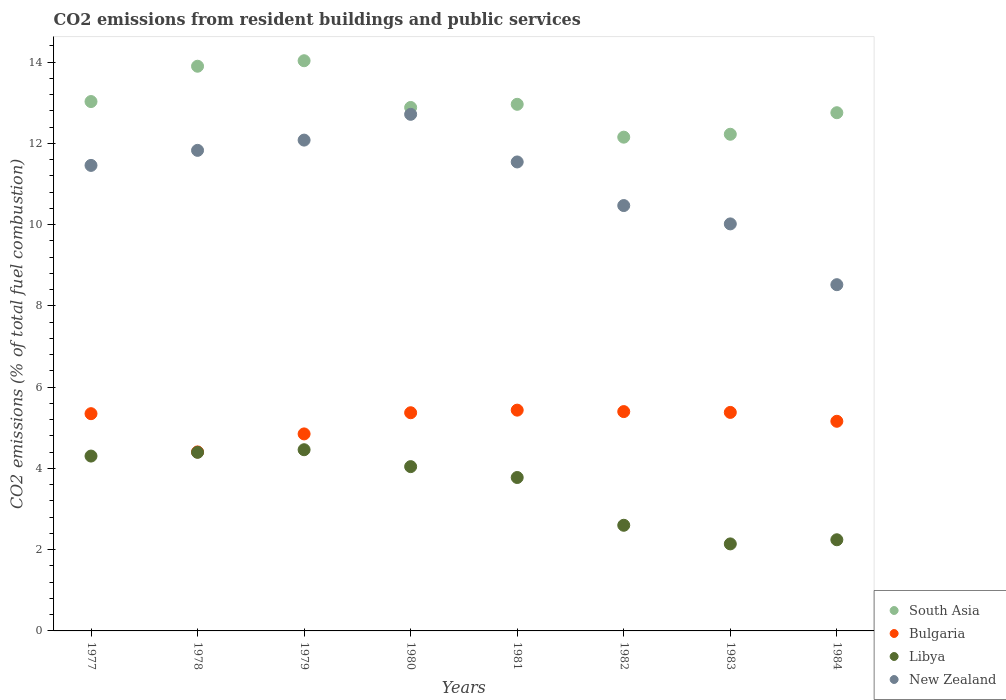How many different coloured dotlines are there?
Make the answer very short. 4. Is the number of dotlines equal to the number of legend labels?
Keep it short and to the point. Yes. What is the total CO2 emitted in Bulgaria in 1982?
Your answer should be very brief. 5.4. Across all years, what is the maximum total CO2 emitted in New Zealand?
Offer a terse response. 12.71. Across all years, what is the minimum total CO2 emitted in New Zealand?
Make the answer very short. 8.52. In which year was the total CO2 emitted in Bulgaria minimum?
Provide a short and direct response. 1978. What is the total total CO2 emitted in Libya in the graph?
Ensure brevity in your answer.  27.96. What is the difference between the total CO2 emitted in New Zealand in 1981 and that in 1984?
Make the answer very short. 3.02. What is the difference between the total CO2 emitted in South Asia in 1978 and the total CO2 emitted in New Zealand in 1977?
Your answer should be very brief. 2.44. What is the average total CO2 emitted in South Asia per year?
Ensure brevity in your answer.  12.99. In the year 1984, what is the difference between the total CO2 emitted in Bulgaria and total CO2 emitted in Libya?
Make the answer very short. 2.92. What is the ratio of the total CO2 emitted in Bulgaria in 1977 to that in 1983?
Provide a short and direct response. 0.99. Is the difference between the total CO2 emitted in Bulgaria in 1979 and 1980 greater than the difference between the total CO2 emitted in Libya in 1979 and 1980?
Provide a short and direct response. No. What is the difference between the highest and the second highest total CO2 emitted in Libya?
Your answer should be compact. 0.06. What is the difference between the highest and the lowest total CO2 emitted in Bulgaria?
Give a very brief answer. 1.03. In how many years, is the total CO2 emitted in New Zealand greater than the average total CO2 emitted in New Zealand taken over all years?
Your answer should be compact. 5. Is the sum of the total CO2 emitted in Bulgaria in 1979 and 1982 greater than the maximum total CO2 emitted in Libya across all years?
Your answer should be compact. Yes. Is it the case that in every year, the sum of the total CO2 emitted in New Zealand and total CO2 emitted in South Asia  is greater than the sum of total CO2 emitted in Bulgaria and total CO2 emitted in Libya?
Give a very brief answer. Yes. Is it the case that in every year, the sum of the total CO2 emitted in Libya and total CO2 emitted in New Zealand  is greater than the total CO2 emitted in South Asia?
Keep it short and to the point. No. Is the total CO2 emitted in Libya strictly greater than the total CO2 emitted in South Asia over the years?
Provide a succinct answer. No. How many dotlines are there?
Your answer should be very brief. 4. How many years are there in the graph?
Keep it short and to the point. 8. What is the difference between two consecutive major ticks on the Y-axis?
Ensure brevity in your answer.  2. Does the graph contain any zero values?
Offer a terse response. No. Where does the legend appear in the graph?
Provide a succinct answer. Bottom right. What is the title of the graph?
Make the answer very short. CO2 emissions from resident buildings and public services. Does "Namibia" appear as one of the legend labels in the graph?
Ensure brevity in your answer.  No. What is the label or title of the Y-axis?
Offer a terse response. CO2 emissions (% of total fuel combustion). What is the CO2 emissions (% of total fuel combustion) in South Asia in 1977?
Make the answer very short. 13.03. What is the CO2 emissions (% of total fuel combustion) in Bulgaria in 1977?
Your answer should be compact. 5.35. What is the CO2 emissions (% of total fuel combustion) in Libya in 1977?
Offer a very short reply. 4.3. What is the CO2 emissions (% of total fuel combustion) of New Zealand in 1977?
Your response must be concise. 11.46. What is the CO2 emissions (% of total fuel combustion) in South Asia in 1978?
Make the answer very short. 13.9. What is the CO2 emissions (% of total fuel combustion) in Bulgaria in 1978?
Provide a short and direct response. 4.4. What is the CO2 emissions (% of total fuel combustion) in Libya in 1978?
Your answer should be very brief. 4.39. What is the CO2 emissions (% of total fuel combustion) of New Zealand in 1978?
Your response must be concise. 11.83. What is the CO2 emissions (% of total fuel combustion) in South Asia in 1979?
Give a very brief answer. 14.03. What is the CO2 emissions (% of total fuel combustion) in Bulgaria in 1979?
Make the answer very short. 4.85. What is the CO2 emissions (% of total fuel combustion) in Libya in 1979?
Ensure brevity in your answer.  4.46. What is the CO2 emissions (% of total fuel combustion) in New Zealand in 1979?
Make the answer very short. 12.08. What is the CO2 emissions (% of total fuel combustion) of South Asia in 1980?
Give a very brief answer. 12.88. What is the CO2 emissions (% of total fuel combustion) of Bulgaria in 1980?
Your answer should be compact. 5.37. What is the CO2 emissions (% of total fuel combustion) of Libya in 1980?
Provide a short and direct response. 4.04. What is the CO2 emissions (% of total fuel combustion) in New Zealand in 1980?
Give a very brief answer. 12.71. What is the CO2 emissions (% of total fuel combustion) in South Asia in 1981?
Make the answer very short. 12.96. What is the CO2 emissions (% of total fuel combustion) in Bulgaria in 1981?
Ensure brevity in your answer.  5.43. What is the CO2 emissions (% of total fuel combustion) of Libya in 1981?
Ensure brevity in your answer.  3.78. What is the CO2 emissions (% of total fuel combustion) of New Zealand in 1981?
Ensure brevity in your answer.  11.54. What is the CO2 emissions (% of total fuel combustion) of South Asia in 1982?
Provide a short and direct response. 12.15. What is the CO2 emissions (% of total fuel combustion) in Bulgaria in 1982?
Give a very brief answer. 5.4. What is the CO2 emissions (% of total fuel combustion) of Libya in 1982?
Your answer should be very brief. 2.6. What is the CO2 emissions (% of total fuel combustion) of New Zealand in 1982?
Your answer should be compact. 10.47. What is the CO2 emissions (% of total fuel combustion) in South Asia in 1983?
Your answer should be very brief. 12.22. What is the CO2 emissions (% of total fuel combustion) of Bulgaria in 1983?
Keep it short and to the point. 5.38. What is the CO2 emissions (% of total fuel combustion) in Libya in 1983?
Make the answer very short. 2.14. What is the CO2 emissions (% of total fuel combustion) of New Zealand in 1983?
Make the answer very short. 10.02. What is the CO2 emissions (% of total fuel combustion) of South Asia in 1984?
Give a very brief answer. 12.75. What is the CO2 emissions (% of total fuel combustion) of Bulgaria in 1984?
Give a very brief answer. 5.16. What is the CO2 emissions (% of total fuel combustion) of Libya in 1984?
Ensure brevity in your answer.  2.24. What is the CO2 emissions (% of total fuel combustion) in New Zealand in 1984?
Offer a very short reply. 8.52. Across all years, what is the maximum CO2 emissions (% of total fuel combustion) in South Asia?
Make the answer very short. 14.03. Across all years, what is the maximum CO2 emissions (% of total fuel combustion) in Bulgaria?
Ensure brevity in your answer.  5.43. Across all years, what is the maximum CO2 emissions (% of total fuel combustion) in Libya?
Your answer should be compact. 4.46. Across all years, what is the maximum CO2 emissions (% of total fuel combustion) of New Zealand?
Ensure brevity in your answer.  12.71. Across all years, what is the minimum CO2 emissions (% of total fuel combustion) of South Asia?
Offer a terse response. 12.15. Across all years, what is the minimum CO2 emissions (% of total fuel combustion) of Bulgaria?
Your answer should be very brief. 4.4. Across all years, what is the minimum CO2 emissions (% of total fuel combustion) of Libya?
Keep it short and to the point. 2.14. Across all years, what is the minimum CO2 emissions (% of total fuel combustion) of New Zealand?
Keep it short and to the point. 8.52. What is the total CO2 emissions (% of total fuel combustion) in South Asia in the graph?
Your answer should be very brief. 103.92. What is the total CO2 emissions (% of total fuel combustion) of Bulgaria in the graph?
Your response must be concise. 41.34. What is the total CO2 emissions (% of total fuel combustion) of Libya in the graph?
Ensure brevity in your answer.  27.96. What is the total CO2 emissions (% of total fuel combustion) of New Zealand in the graph?
Ensure brevity in your answer.  88.62. What is the difference between the CO2 emissions (% of total fuel combustion) in South Asia in 1977 and that in 1978?
Your answer should be very brief. -0.87. What is the difference between the CO2 emissions (% of total fuel combustion) in Bulgaria in 1977 and that in 1978?
Offer a terse response. 0.94. What is the difference between the CO2 emissions (% of total fuel combustion) of Libya in 1977 and that in 1978?
Provide a succinct answer. -0.09. What is the difference between the CO2 emissions (% of total fuel combustion) in New Zealand in 1977 and that in 1978?
Provide a succinct answer. -0.37. What is the difference between the CO2 emissions (% of total fuel combustion) in South Asia in 1977 and that in 1979?
Provide a succinct answer. -1. What is the difference between the CO2 emissions (% of total fuel combustion) in Bulgaria in 1977 and that in 1979?
Offer a terse response. 0.5. What is the difference between the CO2 emissions (% of total fuel combustion) in Libya in 1977 and that in 1979?
Give a very brief answer. -0.16. What is the difference between the CO2 emissions (% of total fuel combustion) of New Zealand in 1977 and that in 1979?
Provide a succinct answer. -0.62. What is the difference between the CO2 emissions (% of total fuel combustion) of South Asia in 1977 and that in 1980?
Your response must be concise. 0.15. What is the difference between the CO2 emissions (% of total fuel combustion) of Bulgaria in 1977 and that in 1980?
Your answer should be very brief. -0.02. What is the difference between the CO2 emissions (% of total fuel combustion) in Libya in 1977 and that in 1980?
Keep it short and to the point. 0.26. What is the difference between the CO2 emissions (% of total fuel combustion) of New Zealand in 1977 and that in 1980?
Your answer should be very brief. -1.26. What is the difference between the CO2 emissions (% of total fuel combustion) in South Asia in 1977 and that in 1981?
Make the answer very short. 0.07. What is the difference between the CO2 emissions (% of total fuel combustion) of Bulgaria in 1977 and that in 1981?
Your response must be concise. -0.09. What is the difference between the CO2 emissions (% of total fuel combustion) in Libya in 1977 and that in 1981?
Offer a very short reply. 0.53. What is the difference between the CO2 emissions (% of total fuel combustion) of New Zealand in 1977 and that in 1981?
Offer a very short reply. -0.08. What is the difference between the CO2 emissions (% of total fuel combustion) of South Asia in 1977 and that in 1982?
Your response must be concise. 0.88. What is the difference between the CO2 emissions (% of total fuel combustion) in Bulgaria in 1977 and that in 1982?
Your response must be concise. -0.05. What is the difference between the CO2 emissions (% of total fuel combustion) of Libya in 1977 and that in 1982?
Keep it short and to the point. 1.7. What is the difference between the CO2 emissions (% of total fuel combustion) in New Zealand in 1977 and that in 1982?
Make the answer very short. 0.99. What is the difference between the CO2 emissions (% of total fuel combustion) of South Asia in 1977 and that in 1983?
Your answer should be compact. 0.8. What is the difference between the CO2 emissions (% of total fuel combustion) in Bulgaria in 1977 and that in 1983?
Your answer should be compact. -0.03. What is the difference between the CO2 emissions (% of total fuel combustion) of Libya in 1977 and that in 1983?
Give a very brief answer. 2.16. What is the difference between the CO2 emissions (% of total fuel combustion) of New Zealand in 1977 and that in 1983?
Your response must be concise. 1.44. What is the difference between the CO2 emissions (% of total fuel combustion) of South Asia in 1977 and that in 1984?
Your response must be concise. 0.27. What is the difference between the CO2 emissions (% of total fuel combustion) in Bulgaria in 1977 and that in 1984?
Keep it short and to the point. 0.19. What is the difference between the CO2 emissions (% of total fuel combustion) in Libya in 1977 and that in 1984?
Offer a terse response. 2.06. What is the difference between the CO2 emissions (% of total fuel combustion) of New Zealand in 1977 and that in 1984?
Keep it short and to the point. 2.94. What is the difference between the CO2 emissions (% of total fuel combustion) in South Asia in 1978 and that in 1979?
Make the answer very short. -0.14. What is the difference between the CO2 emissions (% of total fuel combustion) in Bulgaria in 1978 and that in 1979?
Keep it short and to the point. -0.44. What is the difference between the CO2 emissions (% of total fuel combustion) of Libya in 1978 and that in 1979?
Your response must be concise. -0.06. What is the difference between the CO2 emissions (% of total fuel combustion) of New Zealand in 1978 and that in 1979?
Offer a terse response. -0.25. What is the difference between the CO2 emissions (% of total fuel combustion) of South Asia in 1978 and that in 1980?
Offer a terse response. 1.01. What is the difference between the CO2 emissions (% of total fuel combustion) of Bulgaria in 1978 and that in 1980?
Provide a succinct answer. -0.96. What is the difference between the CO2 emissions (% of total fuel combustion) in Libya in 1978 and that in 1980?
Provide a succinct answer. 0.35. What is the difference between the CO2 emissions (% of total fuel combustion) of New Zealand in 1978 and that in 1980?
Your answer should be very brief. -0.89. What is the difference between the CO2 emissions (% of total fuel combustion) in South Asia in 1978 and that in 1981?
Your response must be concise. 0.94. What is the difference between the CO2 emissions (% of total fuel combustion) of Bulgaria in 1978 and that in 1981?
Offer a terse response. -1.03. What is the difference between the CO2 emissions (% of total fuel combustion) in Libya in 1978 and that in 1981?
Provide a succinct answer. 0.62. What is the difference between the CO2 emissions (% of total fuel combustion) in New Zealand in 1978 and that in 1981?
Offer a very short reply. 0.29. What is the difference between the CO2 emissions (% of total fuel combustion) of South Asia in 1978 and that in 1982?
Your answer should be compact. 1.75. What is the difference between the CO2 emissions (% of total fuel combustion) in Bulgaria in 1978 and that in 1982?
Keep it short and to the point. -0.99. What is the difference between the CO2 emissions (% of total fuel combustion) of Libya in 1978 and that in 1982?
Make the answer very short. 1.79. What is the difference between the CO2 emissions (% of total fuel combustion) of New Zealand in 1978 and that in 1982?
Ensure brevity in your answer.  1.36. What is the difference between the CO2 emissions (% of total fuel combustion) in South Asia in 1978 and that in 1983?
Keep it short and to the point. 1.67. What is the difference between the CO2 emissions (% of total fuel combustion) of Bulgaria in 1978 and that in 1983?
Offer a very short reply. -0.97. What is the difference between the CO2 emissions (% of total fuel combustion) of Libya in 1978 and that in 1983?
Provide a short and direct response. 2.25. What is the difference between the CO2 emissions (% of total fuel combustion) of New Zealand in 1978 and that in 1983?
Ensure brevity in your answer.  1.81. What is the difference between the CO2 emissions (% of total fuel combustion) of South Asia in 1978 and that in 1984?
Make the answer very short. 1.14. What is the difference between the CO2 emissions (% of total fuel combustion) in Bulgaria in 1978 and that in 1984?
Offer a terse response. -0.75. What is the difference between the CO2 emissions (% of total fuel combustion) of Libya in 1978 and that in 1984?
Ensure brevity in your answer.  2.15. What is the difference between the CO2 emissions (% of total fuel combustion) in New Zealand in 1978 and that in 1984?
Provide a short and direct response. 3.31. What is the difference between the CO2 emissions (% of total fuel combustion) in South Asia in 1979 and that in 1980?
Offer a terse response. 1.15. What is the difference between the CO2 emissions (% of total fuel combustion) in Bulgaria in 1979 and that in 1980?
Provide a succinct answer. -0.52. What is the difference between the CO2 emissions (% of total fuel combustion) in Libya in 1979 and that in 1980?
Offer a very short reply. 0.42. What is the difference between the CO2 emissions (% of total fuel combustion) of New Zealand in 1979 and that in 1980?
Provide a succinct answer. -0.63. What is the difference between the CO2 emissions (% of total fuel combustion) of South Asia in 1979 and that in 1981?
Provide a short and direct response. 1.07. What is the difference between the CO2 emissions (% of total fuel combustion) of Bulgaria in 1979 and that in 1981?
Offer a terse response. -0.58. What is the difference between the CO2 emissions (% of total fuel combustion) of Libya in 1979 and that in 1981?
Ensure brevity in your answer.  0.68. What is the difference between the CO2 emissions (% of total fuel combustion) of New Zealand in 1979 and that in 1981?
Ensure brevity in your answer.  0.54. What is the difference between the CO2 emissions (% of total fuel combustion) in South Asia in 1979 and that in 1982?
Provide a short and direct response. 1.88. What is the difference between the CO2 emissions (% of total fuel combustion) of Bulgaria in 1979 and that in 1982?
Ensure brevity in your answer.  -0.55. What is the difference between the CO2 emissions (% of total fuel combustion) of Libya in 1979 and that in 1982?
Provide a short and direct response. 1.86. What is the difference between the CO2 emissions (% of total fuel combustion) of New Zealand in 1979 and that in 1982?
Your answer should be very brief. 1.61. What is the difference between the CO2 emissions (% of total fuel combustion) of South Asia in 1979 and that in 1983?
Give a very brief answer. 1.81. What is the difference between the CO2 emissions (% of total fuel combustion) of Bulgaria in 1979 and that in 1983?
Provide a short and direct response. -0.53. What is the difference between the CO2 emissions (% of total fuel combustion) in Libya in 1979 and that in 1983?
Ensure brevity in your answer.  2.32. What is the difference between the CO2 emissions (% of total fuel combustion) of New Zealand in 1979 and that in 1983?
Offer a terse response. 2.06. What is the difference between the CO2 emissions (% of total fuel combustion) in South Asia in 1979 and that in 1984?
Keep it short and to the point. 1.28. What is the difference between the CO2 emissions (% of total fuel combustion) of Bulgaria in 1979 and that in 1984?
Provide a succinct answer. -0.31. What is the difference between the CO2 emissions (% of total fuel combustion) of Libya in 1979 and that in 1984?
Give a very brief answer. 2.22. What is the difference between the CO2 emissions (% of total fuel combustion) in New Zealand in 1979 and that in 1984?
Your answer should be compact. 3.56. What is the difference between the CO2 emissions (% of total fuel combustion) of South Asia in 1980 and that in 1981?
Your answer should be compact. -0.08. What is the difference between the CO2 emissions (% of total fuel combustion) in Bulgaria in 1980 and that in 1981?
Make the answer very short. -0.06. What is the difference between the CO2 emissions (% of total fuel combustion) of Libya in 1980 and that in 1981?
Provide a succinct answer. 0.27. What is the difference between the CO2 emissions (% of total fuel combustion) in New Zealand in 1980 and that in 1981?
Make the answer very short. 1.17. What is the difference between the CO2 emissions (% of total fuel combustion) in South Asia in 1980 and that in 1982?
Ensure brevity in your answer.  0.73. What is the difference between the CO2 emissions (% of total fuel combustion) in Bulgaria in 1980 and that in 1982?
Provide a short and direct response. -0.03. What is the difference between the CO2 emissions (% of total fuel combustion) in Libya in 1980 and that in 1982?
Provide a succinct answer. 1.44. What is the difference between the CO2 emissions (% of total fuel combustion) of New Zealand in 1980 and that in 1982?
Your response must be concise. 2.25. What is the difference between the CO2 emissions (% of total fuel combustion) in South Asia in 1980 and that in 1983?
Ensure brevity in your answer.  0.66. What is the difference between the CO2 emissions (% of total fuel combustion) in Bulgaria in 1980 and that in 1983?
Make the answer very short. -0.01. What is the difference between the CO2 emissions (% of total fuel combustion) in Libya in 1980 and that in 1983?
Offer a very short reply. 1.9. What is the difference between the CO2 emissions (% of total fuel combustion) of New Zealand in 1980 and that in 1983?
Your response must be concise. 2.7. What is the difference between the CO2 emissions (% of total fuel combustion) of South Asia in 1980 and that in 1984?
Your answer should be very brief. 0.13. What is the difference between the CO2 emissions (% of total fuel combustion) of Bulgaria in 1980 and that in 1984?
Your answer should be compact. 0.21. What is the difference between the CO2 emissions (% of total fuel combustion) of Libya in 1980 and that in 1984?
Your answer should be very brief. 1.8. What is the difference between the CO2 emissions (% of total fuel combustion) of New Zealand in 1980 and that in 1984?
Provide a succinct answer. 4.19. What is the difference between the CO2 emissions (% of total fuel combustion) in South Asia in 1981 and that in 1982?
Provide a short and direct response. 0.81. What is the difference between the CO2 emissions (% of total fuel combustion) of Bulgaria in 1981 and that in 1982?
Your response must be concise. 0.04. What is the difference between the CO2 emissions (% of total fuel combustion) of Libya in 1981 and that in 1982?
Make the answer very short. 1.18. What is the difference between the CO2 emissions (% of total fuel combustion) in New Zealand in 1981 and that in 1982?
Your answer should be compact. 1.07. What is the difference between the CO2 emissions (% of total fuel combustion) of South Asia in 1981 and that in 1983?
Your answer should be compact. 0.74. What is the difference between the CO2 emissions (% of total fuel combustion) in Bulgaria in 1981 and that in 1983?
Ensure brevity in your answer.  0.06. What is the difference between the CO2 emissions (% of total fuel combustion) in Libya in 1981 and that in 1983?
Offer a terse response. 1.63. What is the difference between the CO2 emissions (% of total fuel combustion) in New Zealand in 1981 and that in 1983?
Make the answer very short. 1.52. What is the difference between the CO2 emissions (% of total fuel combustion) in South Asia in 1981 and that in 1984?
Your answer should be very brief. 0.21. What is the difference between the CO2 emissions (% of total fuel combustion) in Bulgaria in 1981 and that in 1984?
Provide a short and direct response. 0.27. What is the difference between the CO2 emissions (% of total fuel combustion) of Libya in 1981 and that in 1984?
Your response must be concise. 1.53. What is the difference between the CO2 emissions (% of total fuel combustion) in New Zealand in 1981 and that in 1984?
Ensure brevity in your answer.  3.02. What is the difference between the CO2 emissions (% of total fuel combustion) in South Asia in 1982 and that in 1983?
Your answer should be very brief. -0.07. What is the difference between the CO2 emissions (% of total fuel combustion) in Libya in 1982 and that in 1983?
Give a very brief answer. 0.46. What is the difference between the CO2 emissions (% of total fuel combustion) in New Zealand in 1982 and that in 1983?
Your answer should be compact. 0.45. What is the difference between the CO2 emissions (% of total fuel combustion) of South Asia in 1982 and that in 1984?
Ensure brevity in your answer.  -0.6. What is the difference between the CO2 emissions (% of total fuel combustion) in Bulgaria in 1982 and that in 1984?
Your answer should be compact. 0.24. What is the difference between the CO2 emissions (% of total fuel combustion) of Libya in 1982 and that in 1984?
Your answer should be very brief. 0.36. What is the difference between the CO2 emissions (% of total fuel combustion) of New Zealand in 1982 and that in 1984?
Make the answer very short. 1.95. What is the difference between the CO2 emissions (% of total fuel combustion) in South Asia in 1983 and that in 1984?
Make the answer very short. -0.53. What is the difference between the CO2 emissions (% of total fuel combustion) in Bulgaria in 1983 and that in 1984?
Your answer should be very brief. 0.22. What is the difference between the CO2 emissions (% of total fuel combustion) in Libya in 1983 and that in 1984?
Offer a terse response. -0.1. What is the difference between the CO2 emissions (% of total fuel combustion) in New Zealand in 1983 and that in 1984?
Keep it short and to the point. 1.5. What is the difference between the CO2 emissions (% of total fuel combustion) in South Asia in 1977 and the CO2 emissions (% of total fuel combustion) in Bulgaria in 1978?
Provide a succinct answer. 8.62. What is the difference between the CO2 emissions (% of total fuel combustion) of South Asia in 1977 and the CO2 emissions (% of total fuel combustion) of Libya in 1978?
Provide a succinct answer. 8.63. What is the difference between the CO2 emissions (% of total fuel combustion) of South Asia in 1977 and the CO2 emissions (% of total fuel combustion) of New Zealand in 1978?
Your answer should be compact. 1.2. What is the difference between the CO2 emissions (% of total fuel combustion) of Bulgaria in 1977 and the CO2 emissions (% of total fuel combustion) of Libya in 1978?
Give a very brief answer. 0.95. What is the difference between the CO2 emissions (% of total fuel combustion) in Bulgaria in 1977 and the CO2 emissions (% of total fuel combustion) in New Zealand in 1978?
Your answer should be very brief. -6.48. What is the difference between the CO2 emissions (% of total fuel combustion) of Libya in 1977 and the CO2 emissions (% of total fuel combustion) of New Zealand in 1978?
Ensure brevity in your answer.  -7.52. What is the difference between the CO2 emissions (% of total fuel combustion) in South Asia in 1977 and the CO2 emissions (% of total fuel combustion) in Bulgaria in 1979?
Your response must be concise. 8.18. What is the difference between the CO2 emissions (% of total fuel combustion) in South Asia in 1977 and the CO2 emissions (% of total fuel combustion) in Libya in 1979?
Your answer should be very brief. 8.57. What is the difference between the CO2 emissions (% of total fuel combustion) of South Asia in 1977 and the CO2 emissions (% of total fuel combustion) of New Zealand in 1979?
Provide a short and direct response. 0.95. What is the difference between the CO2 emissions (% of total fuel combustion) in Bulgaria in 1977 and the CO2 emissions (% of total fuel combustion) in Libya in 1979?
Offer a terse response. 0.89. What is the difference between the CO2 emissions (% of total fuel combustion) of Bulgaria in 1977 and the CO2 emissions (% of total fuel combustion) of New Zealand in 1979?
Ensure brevity in your answer.  -6.73. What is the difference between the CO2 emissions (% of total fuel combustion) of Libya in 1977 and the CO2 emissions (% of total fuel combustion) of New Zealand in 1979?
Your answer should be very brief. -7.78. What is the difference between the CO2 emissions (% of total fuel combustion) of South Asia in 1977 and the CO2 emissions (% of total fuel combustion) of Bulgaria in 1980?
Ensure brevity in your answer.  7.66. What is the difference between the CO2 emissions (% of total fuel combustion) in South Asia in 1977 and the CO2 emissions (% of total fuel combustion) in Libya in 1980?
Your response must be concise. 8.98. What is the difference between the CO2 emissions (% of total fuel combustion) in South Asia in 1977 and the CO2 emissions (% of total fuel combustion) in New Zealand in 1980?
Make the answer very short. 0.31. What is the difference between the CO2 emissions (% of total fuel combustion) of Bulgaria in 1977 and the CO2 emissions (% of total fuel combustion) of Libya in 1980?
Provide a short and direct response. 1.3. What is the difference between the CO2 emissions (% of total fuel combustion) in Bulgaria in 1977 and the CO2 emissions (% of total fuel combustion) in New Zealand in 1980?
Make the answer very short. -7.37. What is the difference between the CO2 emissions (% of total fuel combustion) in Libya in 1977 and the CO2 emissions (% of total fuel combustion) in New Zealand in 1980?
Your response must be concise. -8.41. What is the difference between the CO2 emissions (% of total fuel combustion) of South Asia in 1977 and the CO2 emissions (% of total fuel combustion) of Bulgaria in 1981?
Offer a terse response. 7.59. What is the difference between the CO2 emissions (% of total fuel combustion) in South Asia in 1977 and the CO2 emissions (% of total fuel combustion) in Libya in 1981?
Ensure brevity in your answer.  9.25. What is the difference between the CO2 emissions (% of total fuel combustion) in South Asia in 1977 and the CO2 emissions (% of total fuel combustion) in New Zealand in 1981?
Your answer should be very brief. 1.49. What is the difference between the CO2 emissions (% of total fuel combustion) in Bulgaria in 1977 and the CO2 emissions (% of total fuel combustion) in Libya in 1981?
Offer a very short reply. 1.57. What is the difference between the CO2 emissions (% of total fuel combustion) in Bulgaria in 1977 and the CO2 emissions (% of total fuel combustion) in New Zealand in 1981?
Give a very brief answer. -6.19. What is the difference between the CO2 emissions (% of total fuel combustion) in Libya in 1977 and the CO2 emissions (% of total fuel combustion) in New Zealand in 1981?
Ensure brevity in your answer.  -7.24. What is the difference between the CO2 emissions (% of total fuel combustion) of South Asia in 1977 and the CO2 emissions (% of total fuel combustion) of Bulgaria in 1982?
Keep it short and to the point. 7.63. What is the difference between the CO2 emissions (% of total fuel combustion) in South Asia in 1977 and the CO2 emissions (% of total fuel combustion) in Libya in 1982?
Give a very brief answer. 10.43. What is the difference between the CO2 emissions (% of total fuel combustion) in South Asia in 1977 and the CO2 emissions (% of total fuel combustion) in New Zealand in 1982?
Make the answer very short. 2.56. What is the difference between the CO2 emissions (% of total fuel combustion) in Bulgaria in 1977 and the CO2 emissions (% of total fuel combustion) in Libya in 1982?
Make the answer very short. 2.75. What is the difference between the CO2 emissions (% of total fuel combustion) of Bulgaria in 1977 and the CO2 emissions (% of total fuel combustion) of New Zealand in 1982?
Make the answer very short. -5.12. What is the difference between the CO2 emissions (% of total fuel combustion) of Libya in 1977 and the CO2 emissions (% of total fuel combustion) of New Zealand in 1982?
Make the answer very short. -6.16. What is the difference between the CO2 emissions (% of total fuel combustion) of South Asia in 1977 and the CO2 emissions (% of total fuel combustion) of Bulgaria in 1983?
Offer a terse response. 7.65. What is the difference between the CO2 emissions (% of total fuel combustion) in South Asia in 1977 and the CO2 emissions (% of total fuel combustion) in Libya in 1983?
Provide a short and direct response. 10.89. What is the difference between the CO2 emissions (% of total fuel combustion) in South Asia in 1977 and the CO2 emissions (% of total fuel combustion) in New Zealand in 1983?
Offer a terse response. 3.01. What is the difference between the CO2 emissions (% of total fuel combustion) in Bulgaria in 1977 and the CO2 emissions (% of total fuel combustion) in Libya in 1983?
Your answer should be compact. 3.2. What is the difference between the CO2 emissions (% of total fuel combustion) of Bulgaria in 1977 and the CO2 emissions (% of total fuel combustion) of New Zealand in 1983?
Provide a succinct answer. -4.67. What is the difference between the CO2 emissions (% of total fuel combustion) of Libya in 1977 and the CO2 emissions (% of total fuel combustion) of New Zealand in 1983?
Offer a very short reply. -5.71. What is the difference between the CO2 emissions (% of total fuel combustion) of South Asia in 1977 and the CO2 emissions (% of total fuel combustion) of Bulgaria in 1984?
Your answer should be very brief. 7.87. What is the difference between the CO2 emissions (% of total fuel combustion) of South Asia in 1977 and the CO2 emissions (% of total fuel combustion) of Libya in 1984?
Make the answer very short. 10.78. What is the difference between the CO2 emissions (% of total fuel combustion) of South Asia in 1977 and the CO2 emissions (% of total fuel combustion) of New Zealand in 1984?
Your answer should be very brief. 4.51. What is the difference between the CO2 emissions (% of total fuel combustion) in Bulgaria in 1977 and the CO2 emissions (% of total fuel combustion) in Libya in 1984?
Offer a very short reply. 3.1. What is the difference between the CO2 emissions (% of total fuel combustion) in Bulgaria in 1977 and the CO2 emissions (% of total fuel combustion) in New Zealand in 1984?
Your answer should be very brief. -3.17. What is the difference between the CO2 emissions (% of total fuel combustion) in Libya in 1977 and the CO2 emissions (% of total fuel combustion) in New Zealand in 1984?
Your response must be concise. -4.22. What is the difference between the CO2 emissions (% of total fuel combustion) in South Asia in 1978 and the CO2 emissions (% of total fuel combustion) in Bulgaria in 1979?
Keep it short and to the point. 9.05. What is the difference between the CO2 emissions (% of total fuel combustion) of South Asia in 1978 and the CO2 emissions (% of total fuel combustion) of Libya in 1979?
Provide a succinct answer. 9.44. What is the difference between the CO2 emissions (% of total fuel combustion) in South Asia in 1978 and the CO2 emissions (% of total fuel combustion) in New Zealand in 1979?
Your answer should be very brief. 1.82. What is the difference between the CO2 emissions (% of total fuel combustion) in Bulgaria in 1978 and the CO2 emissions (% of total fuel combustion) in Libya in 1979?
Your response must be concise. -0.05. What is the difference between the CO2 emissions (% of total fuel combustion) in Bulgaria in 1978 and the CO2 emissions (% of total fuel combustion) in New Zealand in 1979?
Provide a succinct answer. -7.67. What is the difference between the CO2 emissions (% of total fuel combustion) of Libya in 1978 and the CO2 emissions (% of total fuel combustion) of New Zealand in 1979?
Your answer should be very brief. -7.68. What is the difference between the CO2 emissions (% of total fuel combustion) in South Asia in 1978 and the CO2 emissions (% of total fuel combustion) in Bulgaria in 1980?
Ensure brevity in your answer.  8.53. What is the difference between the CO2 emissions (% of total fuel combustion) of South Asia in 1978 and the CO2 emissions (% of total fuel combustion) of Libya in 1980?
Give a very brief answer. 9.85. What is the difference between the CO2 emissions (% of total fuel combustion) in South Asia in 1978 and the CO2 emissions (% of total fuel combustion) in New Zealand in 1980?
Offer a very short reply. 1.18. What is the difference between the CO2 emissions (% of total fuel combustion) of Bulgaria in 1978 and the CO2 emissions (% of total fuel combustion) of Libya in 1980?
Your response must be concise. 0.36. What is the difference between the CO2 emissions (% of total fuel combustion) in Bulgaria in 1978 and the CO2 emissions (% of total fuel combustion) in New Zealand in 1980?
Keep it short and to the point. -8.31. What is the difference between the CO2 emissions (% of total fuel combustion) in Libya in 1978 and the CO2 emissions (% of total fuel combustion) in New Zealand in 1980?
Your answer should be very brief. -8.32. What is the difference between the CO2 emissions (% of total fuel combustion) of South Asia in 1978 and the CO2 emissions (% of total fuel combustion) of Bulgaria in 1981?
Offer a terse response. 8.46. What is the difference between the CO2 emissions (% of total fuel combustion) of South Asia in 1978 and the CO2 emissions (% of total fuel combustion) of Libya in 1981?
Make the answer very short. 10.12. What is the difference between the CO2 emissions (% of total fuel combustion) in South Asia in 1978 and the CO2 emissions (% of total fuel combustion) in New Zealand in 1981?
Ensure brevity in your answer.  2.36. What is the difference between the CO2 emissions (% of total fuel combustion) of Bulgaria in 1978 and the CO2 emissions (% of total fuel combustion) of Libya in 1981?
Provide a succinct answer. 0.63. What is the difference between the CO2 emissions (% of total fuel combustion) in Bulgaria in 1978 and the CO2 emissions (% of total fuel combustion) in New Zealand in 1981?
Keep it short and to the point. -7.14. What is the difference between the CO2 emissions (% of total fuel combustion) in Libya in 1978 and the CO2 emissions (% of total fuel combustion) in New Zealand in 1981?
Give a very brief answer. -7.15. What is the difference between the CO2 emissions (% of total fuel combustion) in South Asia in 1978 and the CO2 emissions (% of total fuel combustion) in Bulgaria in 1982?
Your answer should be compact. 8.5. What is the difference between the CO2 emissions (% of total fuel combustion) in South Asia in 1978 and the CO2 emissions (% of total fuel combustion) in Libya in 1982?
Provide a succinct answer. 11.3. What is the difference between the CO2 emissions (% of total fuel combustion) of South Asia in 1978 and the CO2 emissions (% of total fuel combustion) of New Zealand in 1982?
Give a very brief answer. 3.43. What is the difference between the CO2 emissions (% of total fuel combustion) of Bulgaria in 1978 and the CO2 emissions (% of total fuel combustion) of Libya in 1982?
Ensure brevity in your answer.  1.8. What is the difference between the CO2 emissions (% of total fuel combustion) in Bulgaria in 1978 and the CO2 emissions (% of total fuel combustion) in New Zealand in 1982?
Offer a terse response. -6.06. What is the difference between the CO2 emissions (% of total fuel combustion) in Libya in 1978 and the CO2 emissions (% of total fuel combustion) in New Zealand in 1982?
Your answer should be very brief. -6.07. What is the difference between the CO2 emissions (% of total fuel combustion) in South Asia in 1978 and the CO2 emissions (% of total fuel combustion) in Bulgaria in 1983?
Provide a succinct answer. 8.52. What is the difference between the CO2 emissions (% of total fuel combustion) of South Asia in 1978 and the CO2 emissions (% of total fuel combustion) of Libya in 1983?
Your answer should be very brief. 11.76. What is the difference between the CO2 emissions (% of total fuel combustion) in South Asia in 1978 and the CO2 emissions (% of total fuel combustion) in New Zealand in 1983?
Your answer should be very brief. 3.88. What is the difference between the CO2 emissions (% of total fuel combustion) in Bulgaria in 1978 and the CO2 emissions (% of total fuel combustion) in Libya in 1983?
Keep it short and to the point. 2.26. What is the difference between the CO2 emissions (% of total fuel combustion) of Bulgaria in 1978 and the CO2 emissions (% of total fuel combustion) of New Zealand in 1983?
Provide a short and direct response. -5.61. What is the difference between the CO2 emissions (% of total fuel combustion) in Libya in 1978 and the CO2 emissions (% of total fuel combustion) in New Zealand in 1983?
Your answer should be very brief. -5.62. What is the difference between the CO2 emissions (% of total fuel combustion) in South Asia in 1978 and the CO2 emissions (% of total fuel combustion) in Bulgaria in 1984?
Keep it short and to the point. 8.74. What is the difference between the CO2 emissions (% of total fuel combustion) in South Asia in 1978 and the CO2 emissions (% of total fuel combustion) in Libya in 1984?
Offer a very short reply. 11.65. What is the difference between the CO2 emissions (% of total fuel combustion) in South Asia in 1978 and the CO2 emissions (% of total fuel combustion) in New Zealand in 1984?
Your answer should be very brief. 5.38. What is the difference between the CO2 emissions (% of total fuel combustion) in Bulgaria in 1978 and the CO2 emissions (% of total fuel combustion) in Libya in 1984?
Provide a succinct answer. 2.16. What is the difference between the CO2 emissions (% of total fuel combustion) of Bulgaria in 1978 and the CO2 emissions (% of total fuel combustion) of New Zealand in 1984?
Your answer should be compact. -4.12. What is the difference between the CO2 emissions (% of total fuel combustion) in Libya in 1978 and the CO2 emissions (% of total fuel combustion) in New Zealand in 1984?
Keep it short and to the point. -4.13. What is the difference between the CO2 emissions (% of total fuel combustion) in South Asia in 1979 and the CO2 emissions (% of total fuel combustion) in Bulgaria in 1980?
Make the answer very short. 8.66. What is the difference between the CO2 emissions (% of total fuel combustion) in South Asia in 1979 and the CO2 emissions (% of total fuel combustion) in Libya in 1980?
Keep it short and to the point. 9.99. What is the difference between the CO2 emissions (% of total fuel combustion) in South Asia in 1979 and the CO2 emissions (% of total fuel combustion) in New Zealand in 1980?
Your response must be concise. 1.32. What is the difference between the CO2 emissions (% of total fuel combustion) in Bulgaria in 1979 and the CO2 emissions (% of total fuel combustion) in Libya in 1980?
Ensure brevity in your answer.  0.81. What is the difference between the CO2 emissions (% of total fuel combustion) of Bulgaria in 1979 and the CO2 emissions (% of total fuel combustion) of New Zealand in 1980?
Keep it short and to the point. -7.86. What is the difference between the CO2 emissions (% of total fuel combustion) in Libya in 1979 and the CO2 emissions (% of total fuel combustion) in New Zealand in 1980?
Offer a very short reply. -8.25. What is the difference between the CO2 emissions (% of total fuel combustion) in South Asia in 1979 and the CO2 emissions (% of total fuel combustion) in Bulgaria in 1981?
Provide a succinct answer. 8.6. What is the difference between the CO2 emissions (% of total fuel combustion) of South Asia in 1979 and the CO2 emissions (% of total fuel combustion) of Libya in 1981?
Keep it short and to the point. 10.26. What is the difference between the CO2 emissions (% of total fuel combustion) in South Asia in 1979 and the CO2 emissions (% of total fuel combustion) in New Zealand in 1981?
Make the answer very short. 2.49. What is the difference between the CO2 emissions (% of total fuel combustion) of Bulgaria in 1979 and the CO2 emissions (% of total fuel combustion) of Libya in 1981?
Your answer should be compact. 1.07. What is the difference between the CO2 emissions (% of total fuel combustion) of Bulgaria in 1979 and the CO2 emissions (% of total fuel combustion) of New Zealand in 1981?
Make the answer very short. -6.69. What is the difference between the CO2 emissions (% of total fuel combustion) of Libya in 1979 and the CO2 emissions (% of total fuel combustion) of New Zealand in 1981?
Offer a terse response. -7.08. What is the difference between the CO2 emissions (% of total fuel combustion) in South Asia in 1979 and the CO2 emissions (% of total fuel combustion) in Bulgaria in 1982?
Ensure brevity in your answer.  8.63. What is the difference between the CO2 emissions (% of total fuel combustion) in South Asia in 1979 and the CO2 emissions (% of total fuel combustion) in Libya in 1982?
Provide a succinct answer. 11.43. What is the difference between the CO2 emissions (% of total fuel combustion) in South Asia in 1979 and the CO2 emissions (% of total fuel combustion) in New Zealand in 1982?
Provide a short and direct response. 3.56. What is the difference between the CO2 emissions (% of total fuel combustion) in Bulgaria in 1979 and the CO2 emissions (% of total fuel combustion) in Libya in 1982?
Your response must be concise. 2.25. What is the difference between the CO2 emissions (% of total fuel combustion) in Bulgaria in 1979 and the CO2 emissions (% of total fuel combustion) in New Zealand in 1982?
Your response must be concise. -5.62. What is the difference between the CO2 emissions (% of total fuel combustion) of Libya in 1979 and the CO2 emissions (% of total fuel combustion) of New Zealand in 1982?
Keep it short and to the point. -6.01. What is the difference between the CO2 emissions (% of total fuel combustion) of South Asia in 1979 and the CO2 emissions (% of total fuel combustion) of Bulgaria in 1983?
Offer a very short reply. 8.65. What is the difference between the CO2 emissions (% of total fuel combustion) of South Asia in 1979 and the CO2 emissions (% of total fuel combustion) of Libya in 1983?
Provide a short and direct response. 11.89. What is the difference between the CO2 emissions (% of total fuel combustion) in South Asia in 1979 and the CO2 emissions (% of total fuel combustion) in New Zealand in 1983?
Make the answer very short. 4.02. What is the difference between the CO2 emissions (% of total fuel combustion) of Bulgaria in 1979 and the CO2 emissions (% of total fuel combustion) of Libya in 1983?
Your answer should be very brief. 2.71. What is the difference between the CO2 emissions (% of total fuel combustion) of Bulgaria in 1979 and the CO2 emissions (% of total fuel combustion) of New Zealand in 1983?
Provide a succinct answer. -5.17. What is the difference between the CO2 emissions (% of total fuel combustion) of Libya in 1979 and the CO2 emissions (% of total fuel combustion) of New Zealand in 1983?
Offer a terse response. -5.56. What is the difference between the CO2 emissions (% of total fuel combustion) in South Asia in 1979 and the CO2 emissions (% of total fuel combustion) in Bulgaria in 1984?
Provide a succinct answer. 8.87. What is the difference between the CO2 emissions (% of total fuel combustion) in South Asia in 1979 and the CO2 emissions (% of total fuel combustion) in Libya in 1984?
Offer a terse response. 11.79. What is the difference between the CO2 emissions (% of total fuel combustion) in South Asia in 1979 and the CO2 emissions (% of total fuel combustion) in New Zealand in 1984?
Make the answer very short. 5.51. What is the difference between the CO2 emissions (% of total fuel combustion) of Bulgaria in 1979 and the CO2 emissions (% of total fuel combustion) of Libya in 1984?
Provide a short and direct response. 2.6. What is the difference between the CO2 emissions (% of total fuel combustion) of Bulgaria in 1979 and the CO2 emissions (% of total fuel combustion) of New Zealand in 1984?
Offer a very short reply. -3.67. What is the difference between the CO2 emissions (% of total fuel combustion) in Libya in 1979 and the CO2 emissions (% of total fuel combustion) in New Zealand in 1984?
Offer a very short reply. -4.06. What is the difference between the CO2 emissions (% of total fuel combustion) of South Asia in 1980 and the CO2 emissions (% of total fuel combustion) of Bulgaria in 1981?
Your answer should be compact. 7.45. What is the difference between the CO2 emissions (% of total fuel combustion) in South Asia in 1980 and the CO2 emissions (% of total fuel combustion) in Libya in 1981?
Your answer should be very brief. 9.11. What is the difference between the CO2 emissions (% of total fuel combustion) in South Asia in 1980 and the CO2 emissions (% of total fuel combustion) in New Zealand in 1981?
Ensure brevity in your answer.  1.34. What is the difference between the CO2 emissions (% of total fuel combustion) in Bulgaria in 1980 and the CO2 emissions (% of total fuel combustion) in Libya in 1981?
Ensure brevity in your answer.  1.59. What is the difference between the CO2 emissions (% of total fuel combustion) of Bulgaria in 1980 and the CO2 emissions (% of total fuel combustion) of New Zealand in 1981?
Your answer should be compact. -6.17. What is the difference between the CO2 emissions (% of total fuel combustion) in Libya in 1980 and the CO2 emissions (% of total fuel combustion) in New Zealand in 1981?
Provide a short and direct response. -7.5. What is the difference between the CO2 emissions (% of total fuel combustion) in South Asia in 1980 and the CO2 emissions (% of total fuel combustion) in Bulgaria in 1982?
Your response must be concise. 7.48. What is the difference between the CO2 emissions (% of total fuel combustion) in South Asia in 1980 and the CO2 emissions (% of total fuel combustion) in Libya in 1982?
Offer a terse response. 10.28. What is the difference between the CO2 emissions (% of total fuel combustion) of South Asia in 1980 and the CO2 emissions (% of total fuel combustion) of New Zealand in 1982?
Make the answer very short. 2.41. What is the difference between the CO2 emissions (% of total fuel combustion) of Bulgaria in 1980 and the CO2 emissions (% of total fuel combustion) of Libya in 1982?
Ensure brevity in your answer.  2.77. What is the difference between the CO2 emissions (% of total fuel combustion) of Bulgaria in 1980 and the CO2 emissions (% of total fuel combustion) of New Zealand in 1982?
Your answer should be very brief. -5.1. What is the difference between the CO2 emissions (% of total fuel combustion) of Libya in 1980 and the CO2 emissions (% of total fuel combustion) of New Zealand in 1982?
Your answer should be compact. -6.42. What is the difference between the CO2 emissions (% of total fuel combustion) of South Asia in 1980 and the CO2 emissions (% of total fuel combustion) of Bulgaria in 1983?
Your response must be concise. 7.5. What is the difference between the CO2 emissions (% of total fuel combustion) of South Asia in 1980 and the CO2 emissions (% of total fuel combustion) of Libya in 1983?
Your answer should be compact. 10.74. What is the difference between the CO2 emissions (% of total fuel combustion) of South Asia in 1980 and the CO2 emissions (% of total fuel combustion) of New Zealand in 1983?
Offer a very short reply. 2.87. What is the difference between the CO2 emissions (% of total fuel combustion) in Bulgaria in 1980 and the CO2 emissions (% of total fuel combustion) in Libya in 1983?
Provide a succinct answer. 3.23. What is the difference between the CO2 emissions (% of total fuel combustion) in Bulgaria in 1980 and the CO2 emissions (% of total fuel combustion) in New Zealand in 1983?
Provide a succinct answer. -4.65. What is the difference between the CO2 emissions (% of total fuel combustion) of Libya in 1980 and the CO2 emissions (% of total fuel combustion) of New Zealand in 1983?
Offer a very short reply. -5.97. What is the difference between the CO2 emissions (% of total fuel combustion) of South Asia in 1980 and the CO2 emissions (% of total fuel combustion) of Bulgaria in 1984?
Provide a succinct answer. 7.72. What is the difference between the CO2 emissions (% of total fuel combustion) in South Asia in 1980 and the CO2 emissions (% of total fuel combustion) in Libya in 1984?
Your response must be concise. 10.64. What is the difference between the CO2 emissions (% of total fuel combustion) of South Asia in 1980 and the CO2 emissions (% of total fuel combustion) of New Zealand in 1984?
Your answer should be very brief. 4.36. What is the difference between the CO2 emissions (% of total fuel combustion) of Bulgaria in 1980 and the CO2 emissions (% of total fuel combustion) of Libya in 1984?
Offer a terse response. 3.13. What is the difference between the CO2 emissions (% of total fuel combustion) in Bulgaria in 1980 and the CO2 emissions (% of total fuel combustion) in New Zealand in 1984?
Your answer should be compact. -3.15. What is the difference between the CO2 emissions (% of total fuel combustion) in Libya in 1980 and the CO2 emissions (% of total fuel combustion) in New Zealand in 1984?
Provide a succinct answer. -4.48. What is the difference between the CO2 emissions (% of total fuel combustion) of South Asia in 1981 and the CO2 emissions (% of total fuel combustion) of Bulgaria in 1982?
Your answer should be compact. 7.56. What is the difference between the CO2 emissions (% of total fuel combustion) of South Asia in 1981 and the CO2 emissions (% of total fuel combustion) of Libya in 1982?
Keep it short and to the point. 10.36. What is the difference between the CO2 emissions (% of total fuel combustion) of South Asia in 1981 and the CO2 emissions (% of total fuel combustion) of New Zealand in 1982?
Your answer should be very brief. 2.49. What is the difference between the CO2 emissions (% of total fuel combustion) of Bulgaria in 1981 and the CO2 emissions (% of total fuel combustion) of Libya in 1982?
Provide a succinct answer. 2.83. What is the difference between the CO2 emissions (% of total fuel combustion) of Bulgaria in 1981 and the CO2 emissions (% of total fuel combustion) of New Zealand in 1982?
Your answer should be very brief. -5.03. What is the difference between the CO2 emissions (% of total fuel combustion) in Libya in 1981 and the CO2 emissions (% of total fuel combustion) in New Zealand in 1982?
Give a very brief answer. -6.69. What is the difference between the CO2 emissions (% of total fuel combustion) of South Asia in 1981 and the CO2 emissions (% of total fuel combustion) of Bulgaria in 1983?
Your response must be concise. 7.58. What is the difference between the CO2 emissions (% of total fuel combustion) of South Asia in 1981 and the CO2 emissions (% of total fuel combustion) of Libya in 1983?
Ensure brevity in your answer.  10.82. What is the difference between the CO2 emissions (% of total fuel combustion) in South Asia in 1981 and the CO2 emissions (% of total fuel combustion) in New Zealand in 1983?
Provide a succinct answer. 2.94. What is the difference between the CO2 emissions (% of total fuel combustion) in Bulgaria in 1981 and the CO2 emissions (% of total fuel combustion) in Libya in 1983?
Offer a very short reply. 3.29. What is the difference between the CO2 emissions (% of total fuel combustion) in Bulgaria in 1981 and the CO2 emissions (% of total fuel combustion) in New Zealand in 1983?
Offer a terse response. -4.58. What is the difference between the CO2 emissions (% of total fuel combustion) in Libya in 1981 and the CO2 emissions (% of total fuel combustion) in New Zealand in 1983?
Provide a short and direct response. -6.24. What is the difference between the CO2 emissions (% of total fuel combustion) of South Asia in 1981 and the CO2 emissions (% of total fuel combustion) of Bulgaria in 1984?
Offer a very short reply. 7.8. What is the difference between the CO2 emissions (% of total fuel combustion) of South Asia in 1981 and the CO2 emissions (% of total fuel combustion) of Libya in 1984?
Provide a short and direct response. 10.72. What is the difference between the CO2 emissions (% of total fuel combustion) in South Asia in 1981 and the CO2 emissions (% of total fuel combustion) in New Zealand in 1984?
Keep it short and to the point. 4.44. What is the difference between the CO2 emissions (% of total fuel combustion) of Bulgaria in 1981 and the CO2 emissions (% of total fuel combustion) of Libya in 1984?
Your response must be concise. 3.19. What is the difference between the CO2 emissions (% of total fuel combustion) of Bulgaria in 1981 and the CO2 emissions (% of total fuel combustion) of New Zealand in 1984?
Your response must be concise. -3.09. What is the difference between the CO2 emissions (% of total fuel combustion) of Libya in 1981 and the CO2 emissions (% of total fuel combustion) of New Zealand in 1984?
Your response must be concise. -4.75. What is the difference between the CO2 emissions (% of total fuel combustion) of South Asia in 1982 and the CO2 emissions (% of total fuel combustion) of Bulgaria in 1983?
Keep it short and to the point. 6.77. What is the difference between the CO2 emissions (% of total fuel combustion) of South Asia in 1982 and the CO2 emissions (% of total fuel combustion) of Libya in 1983?
Offer a very short reply. 10.01. What is the difference between the CO2 emissions (% of total fuel combustion) in South Asia in 1982 and the CO2 emissions (% of total fuel combustion) in New Zealand in 1983?
Ensure brevity in your answer.  2.13. What is the difference between the CO2 emissions (% of total fuel combustion) of Bulgaria in 1982 and the CO2 emissions (% of total fuel combustion) of Libya in 1983?
Keep it short and to the point. 3.26. What is the difference between the CO2 emissions (% of total fuel combustion) of Bulgaria in 1982 and the CO2 emissions (% of total fuel combustion) of New Zealand in 1983?
Offer a terse response. -4.62. What is the difference between the CO2 emissions (% of total fuel combustion) in Libya in 1982 and the CO2 emissions (% of total fuel combustion) in New Zealand in 1983?
Offer a very short reply. -7.42. What is the difference between the CO2 emissions (% of total fuel combustion) of South Asia in 1982 and the CO2 emissions (% of total fuel combustion) of Bulgaria in 1984?
Offer a terse response. 6.99. What is the difference between the CO2 emissions (% of total fuel combustion) in South Asia in 1982 and the CO2 emissions (% of total fuel combustion) in Libya in 1984?
Your answer should be compact. 9.91. What is the difference between the CO2 emissions (% of total fuel combustion) in South Asia in 1982 and the CO2 emissions (% of total fuel combustion) in New Zealand in 1984?
Your response must be concise. 3.63. What is the difference between the CO2 emissions (% of total fuel combustion) in Bulgaria in 1982 and the CO2 emissions (% of total fuel combustion) in Libya in 1984?
Provide a succinct answer. 3.15. What is the difference between the CO2 emissions (% of total fuel combustion) in Bulgaria in 1982 and the CO2 emissions (% of total fuel combustion) in New Zealand in 1984?
Ensure brevity in your answer.  -3.12. What is the difference between the CO2 emissions (% of total fuel combustion) of Libya in 1982 and the CO2 emissions (% of total fuel combustion) of New Zealand in 1984?
Ensure brevity in your answer.  -5.92. What is the difference between the CO2 emissions (% of total fuel combustion) of South Asia in 1983 and the CO2 emissions (% of total fuel combustion) of Bulgaria in 1984?
Provide a short and direct response. 7.06. What is the difference between the CO2 emissions (% of total fuel combustion) in South Asia in 1983 and the CO2 emissions (% of total fuel combustion) in Libya in 1984?
Keep it short and to the point. 9.98. What is the difference between the CO2 emissions (% of total fuel combustion) in South Asia in 1983 and the CO2 emissions (% of total fuel combustion) in New Zealand in 1984?
Provide a short and direct response. 3.7. What is the difference between the CO2 emissions (% of total fuel combustion) in Bulgaria in 1983 and the CO2 emissions (% of total fuel combustion) in Libya in 1984?
Give a very brief answer. 3.13. What is the difference between the CO2 emissions (% of total fuel combustion) of Bulgaria in 1983 and the CO2 emissions (% of total fuel combustion) of New Zealand in 1984?
Your answer should be very brief. -3.14. What is the difference between the CO2 emissions (% of total fuel combustion) of Libya in 1983 and the CO2 emissions (% of total fuel combustion) of New Zealand in 1984?
Provide a short and direct response. -6.38. What is the average CO2 emissions (% of total fuel combustion) in South Asia per year?
Keep it short and to the point. 12.99. What is the average CO2 emissions (% of total fuel combustion) of Bulgaria per year?
Offer a terse response. 5.17. What is the average CO2 emissions (% of total fuel combustion) in Libya per year?
Your answer should be very brief. 3.5. What is the average CO2 emissions (% of total fuel combustion) of New Zealand per year?
Give a very brief answer. 11.08. In the year 1977, what is the difference between the CO2 emissions (% of total fuel combustion) of South Asia and CO2 emissions (% of total fuel combustion) of Bulgaria?
Provide a succinct answer. 7.68. In the year 1977, what is the difference between the CO2 emissions (% of total fuel combustion) of South Asia and CO2 emissions (% of total fuel combustion) of Libya?
Give a very brief answer. 8.72. In the year 1977, what is the difference between the CO2 emissions (% of total fuel combustion) in South Asia and CO2 emissions (% of total fuel combustion) in New Zealand?
Give a very brief answer. 1.57. In the year 1977, what is the difference between the CO2 emissions (% of total fuel combustion) in Bulgaria and CO2 emissions (% of total fuel combustion) in Libya?
Ensure brevity in your answer.  1.04. In the year 1977, what is the difference between the CO2 emissions (% of total fuel combustion) in Bulgaria and CO2 emissions (% of total fuel combustion) in New Zealand?
Offer a very short reply. -6.11. In the year 1977, what is the difference between the CO2 emissions (% of total fuel combustion) of Libya and CO2 emissions (% of total fuel combustion) of New Zealand?
Make the answer very short. -7.15. In the year 1978, what is the difference between the CO2 emissions (% of total fuel combustion) in South Asia and CO2 emissions (% of total fuel combustion) in Bulgaria?
Provide a short and direct response. 9.49. In the year 1978, what is the difference between the CO2 emissions (% of total fuel combustion) of South Asia and CO2 emissions (% of total fuel combustion) of Libya?
Your response must be concise. 9.5. In the year 1978, what is the difference between the CO2 emissions (% of total fuel combustion) in South Asia and CO2 emissions (% of total fuel combustion) in New Zealand?
Your response must be concise. 2.07. In the year 1978, what is the difference between the CO2 emissions (% of total fuel combustion) of Bulgaria and CO2 emissions (% of total fuel combustion) of Libya?
Your answer should be compact. 0.01. In the year 1978, what is the difference between the CO2 emissions (% of total fuel combustion) in Bulgaria and CO2 emissions (% of total fuel combustion) in New Zealand?
Provide a succinct answer. -7.42. In the year 1978, what is the difference between the CO2 emissions (% of total fuel combustion) of Libya and CO2 emissions (% of total fuel combustion) of New Zealand?
Ensure brevity in your answer.  -7.43. In the year 1979, what is the difference between the CO2 emissions (% of total fuel combustion) in South Asia and CO2 emissions (% of total fuel combustion) in Bulgaria?
Provide a short and direct response. 9.18. In the year 1979, what is the difference between the CO2 emissions (% of total fuel combustion) in South Asia and CO2 emissions (% of total fuel combustion) in Libya?
Ensure brevity in your answer.  9.57. In the year 1979, what is the difference between the CO2 emissions (% of total fuel combustion) in South Asia and CO2 emissions (% of total fuel combustion) in New Zealand?
Provide a succinct answer. 1.95. In the year 1979, what is the difference between the CO2 emissions (% of total fuel combustion) in Bulgaria and CO2 emissions (% of total fuel combustion) in Libya?
Provide a succinct answer. 0.39. In the year 1979, what is the difference between the CO2 emissions (% of total fuel combustion) of Bulgaria and CO2 emissions (% of total fuel combustion) of New Zealand?
Offer a very short reply. -7.23. In the year 1979, what is the difference between the CO2 emissions (% of total fuel combustion) of Libya and CO2 emissions (% of total fuel combustion) of New Zealand?
Offer a very short reply. -7.62. In the year 1980, what is the difference between the CO2 emissions (% of total fuel combustion) of South Asia and CO2 emissions (% of total fuel combustion) of Bulgaria?
Keep it short and to the point. 7.51. In the year 1980, what is the difference between the CO2 emissions (% of total fuel combustion) of South Asia and CO2 emissions (% of total fuel combustion) of Libya?
Make the answer very short. 8.84. In the year 1980, what is the difference between the CO2 emissions (% of total fuel combustion) of South Asia and CO2 emissions (% of total fuel combustion) of New Zealand?
Make the answer very short. 0.17. In the year 1980, what is the difference between the CO2 emissions (% of total fuel combustion) of Bulgaria and CO2 emissions (% of total fuel combustion) of Libya?
Make the answer very short. 1.33. In the year 1980, what is the difference between the CO2 emissions (% of total fuel combustion) in Bulgaria and CO2 emissions (% of total fuel combustion) in New Zealand?
Offer a very short reply. -7.34. In the year 1980, what is the difference between the CO2 emissions (% of total fuel combustion) in Libya and CO2 emissions (% of total fuel combustion) in New Zealand?
Provide a succinct answer. -8.67. In the year 1981, what is the difference between the CO2 emissions (% of total fuel combustion) in South Asia and CO2 emissions (% of total fuel combustion) in Bulgaria?
Ensure brevity in your answer.  7.53. In the year 1981, what is the difference between the CO2 emissions (% of total fuel combustion) in South Asia and CO2 emissions (% of total fuel combustion) in Libya?
Your answer should be very brief. 9.18. In the year 1981, what is the difference between the CO2 emissions (% of total fuel combustion) of South Asia and CO2 emissions (% of total fuel combustion) of New Zealand?
Provide a short and direct response. 1.42. In the year 1981, what is the difference between the CO2 emissions (% of total fuel combustion) in Bulgaria and CO2 emissions (% of total fuel combustion) in Libya?
Provide a succinct answer. 1.66. In the year 1981, what is the difference between the CO2 emissions (% of total fuel combustion) in Bulgaria and CO2 emissions (% of total fuel combustion) in New Zealand?
Your answer should be compact. -6.11. In the year 1981, what is the difference between the CO2 emissions (% of total fuel combustion) in Libya and CO2 emissions (% of total fuel combustion) in New Zealand?
Offer a very short reply. -7.77. In the year 1982, what is the difference between the CO2 emissions (% of total fuel combustion) in South Asia and CO2 emissions (% of total fuel combustion) in Bulgaria?
Give a very brief answer. 6.75. In the year 1982, what is the difference between the CO2 emissions (% of total fuel combustion) in South Asia and CO2 emissions (% of total fuel combustion) in Libya?
Offer a terse response. 9.55. In the year 1982, what is the difference between the CO2 emissions (% of total fuel combustion) of South Asia and CO2 emissions (% of total fuel combustion) of New Zealand?
Your answer should be compact. 1.68. In the year 1982, what is the difference between the CO2 emissions (% of total fuel combustion) of Bulgaria and CO2 emissions (% of total fuel combustion) of Libya?
Offer a terse response. 2.8. In the year 1982, what is the difference between the CO2 emissions (% of total fuel combustion) of Bulgaria and CO2 emissions (% of total fuel combustion) of New Zealand?
Make the answer very short. -5.07. In the year 1982, what is the difference between the CO2 emissions (% of total fuel combustion) of Libya and CO2 emissions (% of total fuel combustion) of New Zealand?
Ensure brevity in your answer.  -7.87. In the year 1983, what is the difference between the CO2 emissions (% of total fuel combustion) in South Asia and CO2 emissions (% of total fuel combustion) in Bulgaria?
Provide a succinct answer. 6.84. In the year 1983, what is the difference between the CO2 emissions (% of total fuel combustion) of South Asia and CO2 emissions (% of total fuel combustion) of Libya?
Make the answer very short. 10.08. In the year 1983, what is the difference between the CO2 emissions (% of total fuel combustion) of South Asia and CO2 emissions (% of total fuel combustion) of New Zealand?
Provide a succinct answer. 2.21. In the year 1983, what is the difference between the CO2 emissions (% of total fuel combustion) in Bulgaria and CO2 emissions (% of total fuel combustion) in Libya?
Your response must be concise. 3.24. In the year 1983, what is the difference between the CO2 emissions (% of total fuel combustion) of Bulgaria and CO2 emissions (% of total fuel combustion) of New Zealand?
Provide a short and direct response. -4.64. In the year 1983, what is the difference between the CO2 emissions (% of total fuel combustion) of Libya and CO2 emissions (% of total fuel combustion) of New Zealand?
Keep it short and to the point. -7.88. In the year 1984, what is the difference between the CO2 emissions (% of total fuel combustion) in South Asia and CO2 emissions (% of total fuel combustion) in Bulgaria?
Ensure brevity in your answer.  7.59. In the year 1984, what is the difference between the CO2 emissions (% of total fuel combustion) in South Asia and CO2 emissions (% of total fuel combustion) in Libya?
Keep it short and to the point. 10.51. In the year 1984, what is the difference between the CO2 emissions (% of total fuel combustion) of South Asia and CO2 emissions (% of total fuel combustion) of New Zealand?
Make the answer very short. 4.23. In the year 1984, what is the difference between the CO2 emissions (% of total fuel combustion) in Bulgaria and CO2 emissions (% of total fuel combustion) in Libya?
Ensure brevity in your answer.  2.92. In the year 1984, what is the difference between the CO2 emissions (% of total fuel combustion) in Bulgaria and CO2 emissions (% of total fuel combustion) in New Zealand?
Your response must be concise. -3.36. In the year 1984, what is the difference between the CO2 emissions (% of total fuel combustion) in Libya and CO2 emissions (% of total fuel combustion) in New Zealand?
Offer a terse response. -6.28. What is the ratio of the CO2 emissions (% of total fuel combustion) in South Asia in 1977 to that in 1978?
Your answer should be compact. 0.94. What is the ratio of the CO2 emissions (% of total fuel combustion) in Bulgaria in 1977 to that in 1978?
Provide a short and direct response. 1.21. What is the ratio of the CO2 emissions (% of total fuel combustion) of Libya in 1977 to that in 1978?
Make the answer very short. 0.98. What is the ratio of the CO2 emissions (% of total fuel combustion) in New Zealand in 1977 to that in 1978?
Offer a terse response. 0.97. What is the ratio of the CO2 emissions (% of total fuel combustion) of South Asia in 1977 to that in 1979?
Give a very brief answer. 0.93. What is the ratio of the CO2 emissions (% of total fuel combustion) in Bulgaria in 1977 to that in 1979?
Your answer should be compact. 1.1. What is the ratio of the CO2 emissions (% of total fuel combustion) of Libya in 1977 to that in 1979?
Keep it short and to the point. 0.96. What is the ratio of the CO2 emissions (% of total fuel combustion) of New Zealand in 1977 to that in 1979?
Ensure brevity in your answer.  0.95. What is the ratio of the CO2 emissions (% of total fuel combustion) of South Asia in 1977 to that in 1980?
Offer a very short reply. 1.01. What is the ratio of the CO2 emissions (% of total fuel combustion) in Bulgaria in 1977 to that in 1980?
Your answer should be compact. 1. What is the ratio of the CO2 emissions (% of total fuel combustion) in Libya in 1977 to that in 1980?
Keep it short and to the point. 1.06. What is the ratio of the CO2 emissions (% of total fuel combustion) in New Zealand in 1977 to that in 1980?
Your answer should be very brief. 0.9. What is the ratio of the CO2 emissions (% of total fuel combustion) in South Asia in 1977 to that in 1981?
Offer a very short reply. 1.01. What is the ratio of the CO2 emissions (% of total fuel combustion) in Bulgaria in 1977 to that in 1981?
Your answer should be very brief. 0.98. What is the ratio of the CO2 emissions (% of total fuel combustion) of Libya in 1977 to that in 1981?
Ensure brevity in your answer.  1.14. What is the ratio of the CO2 emissions (% of total fuel combustion) of South Asia in 1977 to that in 1982?
Provide a succinct answer. 1.07. What is the ratio of the CO2 emissions (% of total fuel combustion) of Bulgaria in 1977 to that in 1982?
Provide a short and direct response. 0.99. What is the ratio of the CO2 emissions (% of total fuel combustion) in Libya in 1977 to that in 1982?
Provide a short and direct response. 1.66. What is the ratio of the CO2 emissions (% of total fuel combustion) in New Zealand in 1977 to that in 1982?
Give a very brief answer. 1.09. What is the ratio of the CO2 emissions (% of total fuel combustion) in South Asia in 1977 to that in 1983?
Ensure brevity in your answer.  1.07. What is the ratio of the CO2 emissions (% of total fuel combustion) in Bulgaria in 1977 to that in 1983?
Your answer should be very brief. 0.99. What is the ratio of the CO2 emissions (% of total fuel combustion) in Libya in 1977 to that in 1983?
Provide a short and direct response. 2.01. What is the ratio of the CO2 emissions (% of total fuel combustion) in New Zealand in 1977 to that in 1983?
Offer a terse response. 1.14. What is the ratio of the CO2 emissions (% of total fuel combustion) of South Asia in 1977 to that in 1984?
Offer a very short reply. 1.02. What is the ratio of the CO2 emissions (% of total fuel combustion) in Bulgaria in 1977 to that in 1984?
Offer a very short reply. 1.04. What is the ratio of the CO2 emissions (% of total fuel combustion) of Libya in 1977 to that in 1984?
Your answer should be very brief. 1.92. What is the ratio of the CO2 emissions (% of total fuel combustion) in New Zealand in 1977 to that in 1984?
Offer a very short reply. 1.34. What is the ratio of the CO2 emissions (% of total fuel combustion) in South Asia in 1978 to that in 1979?
Ensure brevity in your answer.  0.99. What is the ratio of the CO2 emissions (% of total fuel combustion) of Bulgaria in 1978 to that in 1979?
Ensure brevity in your answer.  0.91. What is the ratio of the CO2 emissions (% of total fuel combustion) in Libya in 1978 to that in 1979?
Make the answer very short. 0.99. What is the ratio of the CO2 emissions (% of total fuel combustion) in New Zealand in 1978 to that in 1979?
Your answer should be very brief. 0.98. What is the ratio of the CO2 emissions (% of total fuel combustion) in South Asia in 1978 to that in 1980?
Your response must be concise. 1.08. What is the ratio of the CO2 emissions (% of total fuel combustion) of Bulgaria in 1978 to that in 1980?
Keep it short and to the point. 0.82. What is the ratio of the CO2 emissions (% of total fuel combustion) in Libya in 1978 to that in 1980?
Offer a terse response. 1.09. What is the ratio of the CO2 emissions (% of total fuel combustion) of New Zealand in 1978 to that in 1980?
Provide a succinct answer. 0.93. What is the ratio of the CO2 emissions (% of total fuel combustion) of South Asia in 1978 to that in 1981?
Your answer should be compact. 1.07. What is the ratio of the CO2 emissions (% of total fuel combustion) of Bulgaria in 1978 to that in 1981?
Provide a short and direct response. 0.81. What is the ratio of the CO2 emissions (% of total fuel combustion) in Libya in 1978 to that in 1981?
Your answer should be compact. 1.16. What is the ratio of the CO2 emissions (% of total fuel combustion) of New Zealand in 1978 to that in 1981?
Provide a succinct answer. 1.02. What is the ratio of the CO2 emissions (% of total fuel combustion) in South Asia in 1978 to that in 1982?
Offer a terse response. 1.14. What is the ratio of the CO2 emissions (% of total fuel combustion) of Bulgaria in 1978 to that in 1982?
Provide a short and direct response. 0.82. What is the ratio of the CO2 emissions (% of total fuel combustion) in Libya in 1978 to that in 1982?
Ensure brevity in your answer.  1.69. What is the ratio of the CO2 emissions (% of total fuel combustion) of New Zealand in 1978 to that in 1982?
Your response must be concise. 1.13. What is the ratio of the CO2 emissions (% of total fuel combustion) in South Asia in 1978 to that in 1983?
Give a very brief answer. 1.14. What is the ratio of the CO2 emissions (% of total fuel combustion) of Bulgaria in 1978 to that in 1983?
Offer a terse response. 0.82. What is the ratio of the CO2 emissions (% of total fuel combustion) of Libya in 1978 to that in 1983?
Your answer should be very brief. 2.05. What is the ratio of the CO2 emissions (% of total fuel combustion) of New Zealand in 1978 to that in 1983?
Your answer should be very brief. 1.18. What is the ratio of the CO2 emissions (% of total fuel combustion) in South Asia in 1978 to that in 1984?
Keep it short and to the point. 1.09. What is the ratio of the CO2 emissions (% of total fuel combustion) of Bulgaria in 1978 to that in 1984?
Offer a very short reply. 0.85. What is the ratio of the CO2 emissions (% of total fuel combustion) of Libya in 1978 to that in 1984?
Ensure brevity in your answer.  1.96. What is the ratio of the CO2 emissions (% of total fuel combustion) of New Zealand in 1978 to that in 1984?
Provide a short and direct response. 1.39. What is the ratio of the CO2 emissions (% of total fuel combustion) in South Asia in 1979 to that in 1980?
Keep it short and to the point. 1.09. What is the ratio of the CO2 emissions (% of total fuel combustion) in Bulgaria in 1979 to that in 1980?
Your answer should be compact. 0.9. What is the ratio of the CO2 emissions (% of total fuel combustion) in Libya in 1979 to that in 1980?
Your answer should be compact. 1.1. What is the ratio of the CO2 emissions (% of total fuel combustion) in New Zealand in 1979 to that in 1980?
Your response must be concise. 0.95. What is the ratio of the CO2 emissions (% of total fuel combustion) of South Asia in 1979 to that in 1981?
Make the answer very short. 1.08. What is the ratio of the CO2 emissions (% of total fuel combustion) in Bulgaria in 1979 to that in 1981?
Ensure brevity in your answer.  0.89. What is the ratio of the CO2 emissions (% of total fuel combustion) of Libya in 1979 to that in 1981?
Keep it short and to the point. 1.18. What is the ratio of the CO2 emissions (% of total fuel combustion) in New Zealand in 1979 to that in 1981?
Make the answer very short. 1.05. What is the ratio of the CO2 emissions (% of total fuel combustion) in South Asia in 1979 to that in 1982?
Give a very brief answer. 1.15. What is the ratio of the CO2 emissions (% of total fuel combustion) in Bulgaria in 1979 to that in 1982?
Make the answer very short. 0.9. What is the ratio of the CO2 emissions (% of total fuel combustion) in Libya in 1979 to that in 1982?
Provide a succinct answer. 1.72. What is the ratio of the CO2 emissions (% of total fuel combustion) of New Zealand in 1979 to that in 1982?
Offer a very short reply. 1.15. What is the ratio of the CO2 emissions (% of total fuel combustion) of South Asia in 1979 to that in 1983?
Ensure brevity in your answer.  1.15. What is the ratio of the CO2 emissions (% of total fuel combustion) in Bulgaria in 1979 to that in 1983?
Keep it short and to the point. 0.9. What is the ratio of the CO2 emissions (% of total fuel combustion) of Libya in 1979 to that in 1983?
Offer a terse response. 2.08. What is the ratio of the CO2 emissions (% of total fuel combustion) of New Zealand in 1979 to that in 1983?
Provide a short and direct response. 1.21. What is the ratio of the CO2 emissions (% of total fuel combustion) in South Asia in 1979 to that in 1984?
Offer a terse response. 1.1. What is the ratio of the CO2 emissions (% of total fuel combustion) of Bulgaria in 1979 to that in 1984?
Give a very brief answer. 0.94. What is the ratio of the CO2 emissions (% of total fuel combustion) in Libya in 1979 to that in 1984?
Give a very brief answer. 1.99. What is the ratio of the CO2 emissions (% of total fuel combustion) of New Zealand in 1979 to that in 1984?
Offer a very short reply. 1.42. What is the ratio of the CO2 emissions (% of total fuel combustion) in South Asia in 1980 to that in 1981?
Keep it short and to the point. 0.99. What is the ratio of the CO2 emissions (% of total fuel combustion) of Libya in 1980 to that in 1981?
Your answer should be very brief. 1.07. What is the ratio of the CO2 emissions (% of total fuel combustion) of New Zealand in 1980 to that in 1981?
Your answer should be compact. 1.1. What is the ratio of the CO2 emissions (% of total fuel combustion) of South Asia in 1980 to that in 1982?
Provide a succinct answer. 1.06. What is the ratio of the CO2 emissions (% of total fuel combustion) of Libya in 1980 to that in 1982?
Offer a very short reply. 1.56. What is the ratio of the CO2 emissions (% of total fuel combustion) in New Zealand in 1980 to that in 1982?
Give a very brief answer. 1.21. What is the ratio of the CO2 emissions (% of total fuel combustion) of South Asia in 1980 to that in 1983?
Provide a succinct answer. 1.05. What is the ratio of the CO2 emissions (% of total fuel combustion) in Libya in 1980 to that in 1983?
Your response must be concise. 1.89. What is the ratio of the CO2 emissions (% of total fuel combustion) of New Zealand in 1980 to that in 1983?
Give a very brief answer. 1.27. What is the ratio of the CO2 emissions (% of total fuel combustion) of Bulgaria in 1980 to that in 1984?
Your response must be concise. 1.04. What is the ratio of the CO2 emissions (% of total fuel combustion) of Libya in 1980 to that in 1984?
Your answer should be compact. 1.8. What is the ratio of the CO2 emissions (% of total fuel combustion) of New Zealand in 1980 to that in 1984?
Your response must be concise. 1.49. What is the ratio of the CO2 emissions (% of total fuel combustion) of South Asia in 1981 to that in 1982?
Offer a terse response. 1.07. What is the ratio of the CO2 emissions (% of total fuel combustion) of Bulgaria in 1981 to that in 1982?
Your response must be concise. 1.01. What is the ratio of the CO2 emissions (% of total fuel combustion) of Libya in 1981 to that in 1982?
Keep it short and to the point. 1.45. What is the ratio of the CO2 emissions (% of total fuel combustion) in New Zealand in 1981 to that in 1982?
Your answer should be very brief. 1.1. What is the ratio of the CO2 emissions (% of total fuel combustion) in South Asia in 1981 to that in 1983?
Offer a terse response. 1.06. What is the ratio of the CO2 emissions (% of total fuel combustion) of Bulgaria in 1981 to that in 1983?
Ensure brevity in your answer.  1.01. What is the ratio of the CO2 emissions (% of total fuel combustion) of Libya in 1981 to that in 1983?
Your answer should be compact. 1.76. What is the ratio of the CO2 emissions (% of total fuel combustion) in New Zealand in 1981 to that in 1983?
Keep it short and to the point. 1.15. What is the ratio of the CO2 emissions (% of total fuel combustion) in South Asia in 1981 to that in 1984?
Keep it short and to the point. 1.02. What is the ratio of the CO2 emissions (% of total fuel combustion) in Bulgaria in 1981 to that in 1984?
Offer a terse response. 1.05. What is the ratio of the CO2 emissions (% of total fuel combustion) of Libya in 1981 to that in 1984?
Offer a terse response. 1.68. What is the ratio of the CO2 emissions (% of total fuel combustion) of New Zealand in 1981 to that in 1984?
Provide a short and direct response. 1.35. What is the ratio of the CO2 emissions (% of total fuel combustion) of South Asia in 1982 to that in 1983?
Give a very brief answer. 0.99. What is the ratio of the CO2 emissions (% of total fuel combustion) of Libya in 1982 to that in 1983?
Ensure brevity in your answer.  1.21. What is the ratio of the CO2 emissions (% of total fuel combustion) in New Zealand in 1982 to that in 1983?
Give a very brief answer. 1.04. What is the ratio of the CO2 emissions (% of total fuel combustion) of South Asia in 1982 to that in 1984?
Your response must be concise. 0.95. What is the ratio of the CO2 emissions (% of total fuel combustion) in Bulgaria in 1982 to that in 1984?
Offer a terse response. 1.05. What is the ratio of the CO2 emissions (% of total fuel combustion) in Libya in 1982 to that in 1984?
Offer a very short reply. 1.16. What is the ratio of the CO2 emissions (% of total fuel combustion) of New Zealand in 1982 to that in 1984?
Give a very brief answer. 1.23. What is the ratio of the CO2 emissions (% of total fuel combustion) in South Asia in 1983 to that in 1984?
Your answer should be very brief. 0.96. What is the ratio of the CO2 emissions (% of total fuel combustion) in Bulgaria in 1983 to that in 1984?
Give a very brief answer. 1.04. What is the ratio of the CO2 emissions (% of total fuel combustion) in Libya in 1983 to that in 1984?
Make the answer very short. 0.95. What is the ratio of the CO2 emissions (% of total fuel combustion) in New Zealand in 1983 to that in 1984?
Ensure brevity in your answer.  1.18. What is the difference between the highest and the second highest CO2 emissions (% of total fuel combustion) in South Asia?
Offer a terse response. 0.14. What is the difference between the highest and the second highest CO2 emissions (% of total fuel combustion) in Bulgaria?
Offer a very short reply. 0.04. What is the difference between the highest and the second highest CO2 emissions (% of total fuel combustion) in Libya?
Your answer should be very brief. 0.06. What is the difference between the highest and the second highest CO2 emissions (% of total fuel combustion) of New Zealand?
Offer a very short reply. 0.63. What is the difference between the highest and the lowest CO2 emissions (% of total fuel combustion) in South Asia?
Make the answer very short. 1.88. What is the difference between the highest and the lowest CO2 emissions (% of total fuel combustion) in Bulgaria?
Your answer should be very brief. 1.03. What is the difference between the highest and the lowest CO2 emissions (% of total fuel combustion) of Libya?
Offer a terse response. 2.32. What is the difference between the highest and the lowest CO2 emissions (% of total fuel combustion) in New Zealand?
Your answer should be very brief. 4.19. 